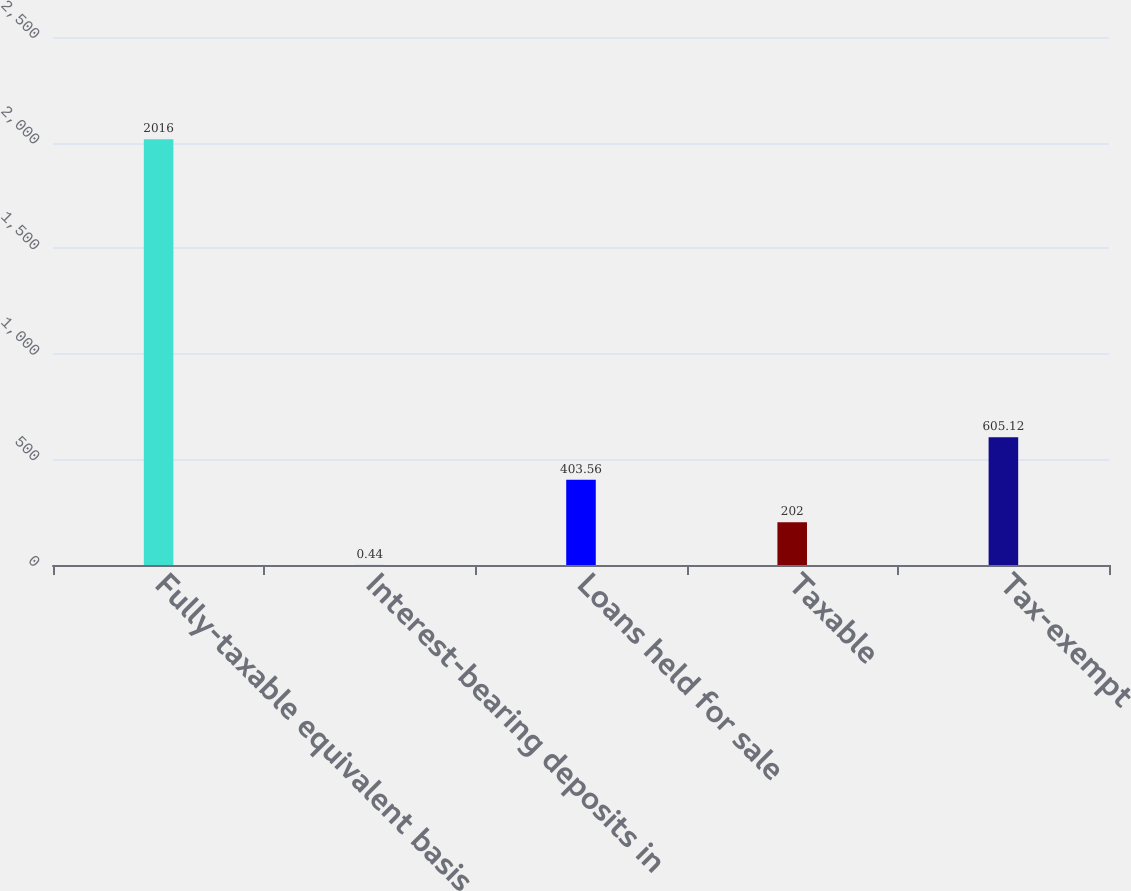Convert chart. <chart><loc_0><loc_0><loc_500><loc_500><bar_chart><fcel>Fully-taxable equivalent basis<fcel>Interest-bearing deposits in<fcel>Loans held for sale<fcel>Taxable<fcel>Tax-exempt<nl><fcel>2016<fcel>0.44<fcel>403.56<fcel>202<fcel>605.12<nl></chart> 